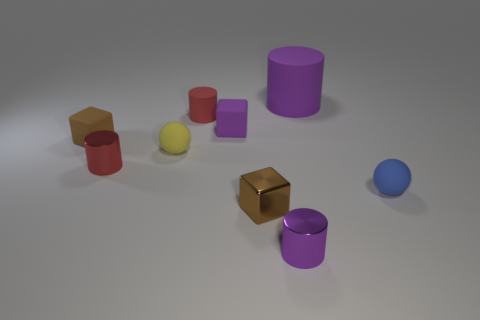Add 1 purple metal blocks. How many objects exist? 10 Subtract all blocks. How many objects are left? 6 Add 5 tiny red cylinders. How many tiny red cylinders exist? 7 Subtract 0 yellow blocks. How many objects are left? 9 Subtract all small yellow rubber balls. Subtract all blue objects. How many objects are left? 7 Add 7 blocks. How many blocks are left? 10 